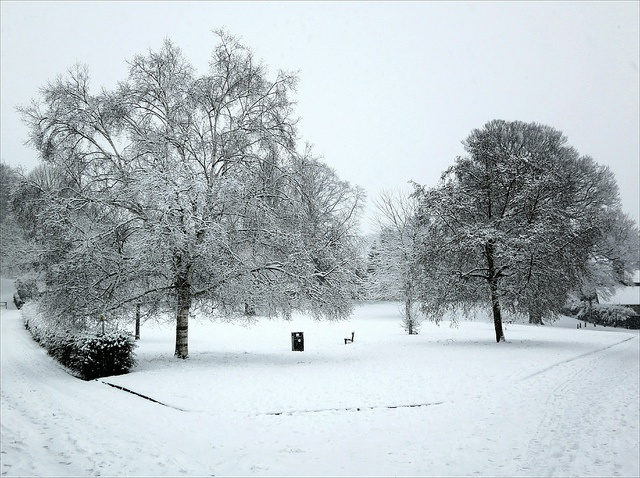Describe the objects in this image and their specific colors. I can see a bench in darkgray, black, and gray tones in this image. 